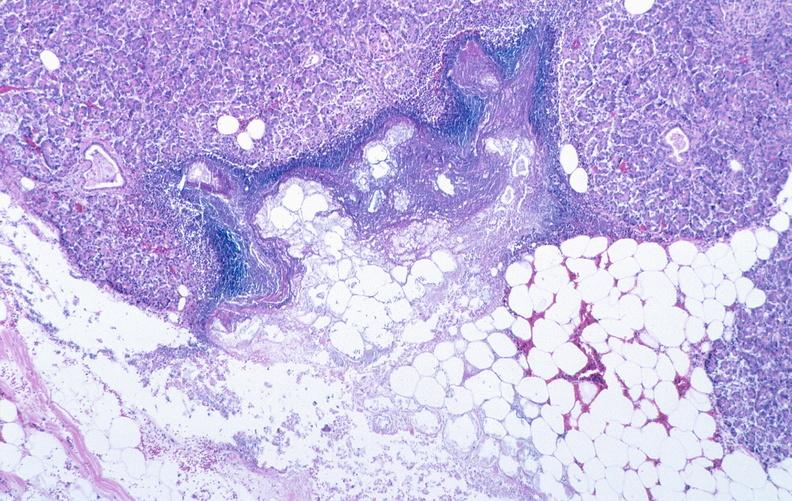does papillary adenoma show pancreatic fat necrosis?
Answer the question using a single word or phrase. No 